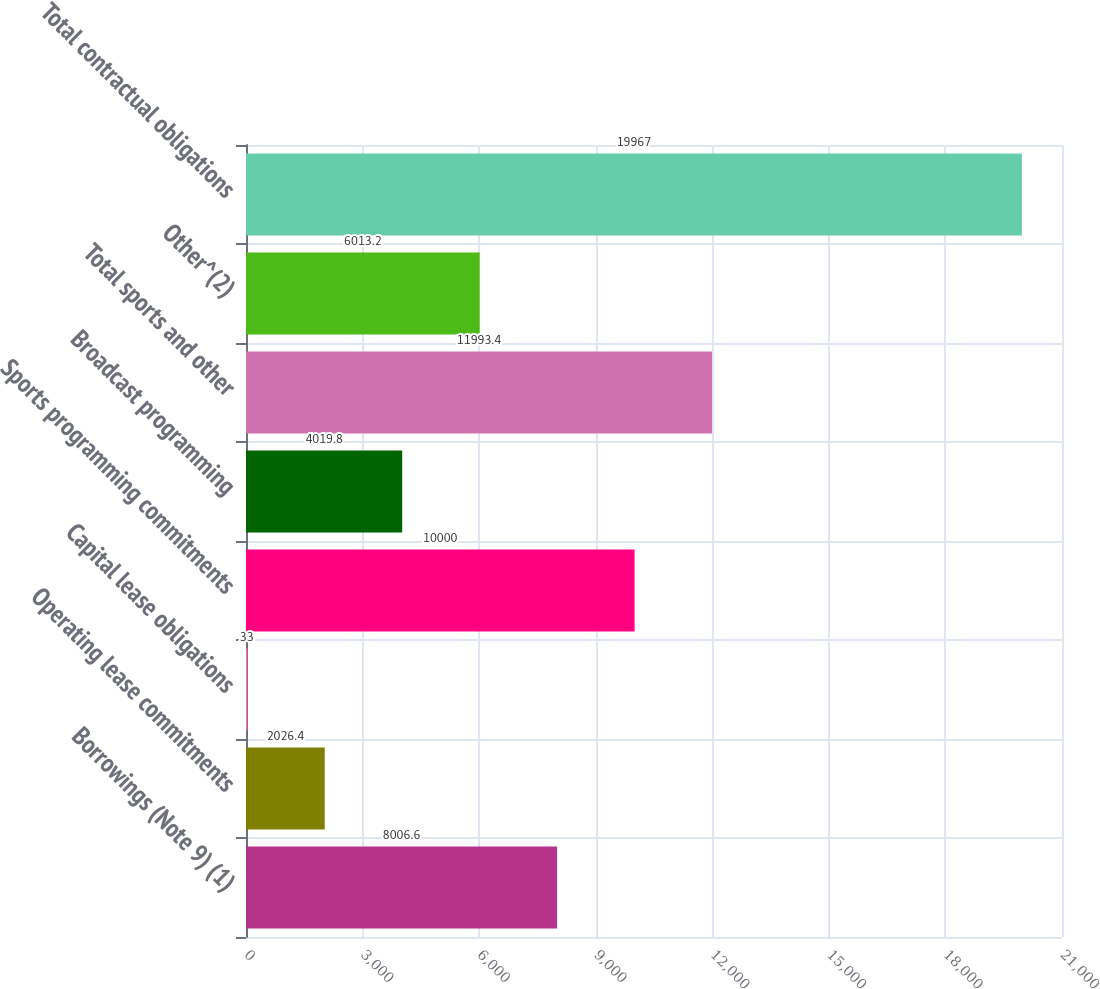Convert chart. <chart><loc_0><loc_0><loc_500><loc_500><bar_chart><fcel>Borrowings (Note 9) (1)<fcel>Operating lease commitments<fcel>Capital lease obligations<fcel>Sports programming commitments<fcel>Broadcast programming<fcel>Total sports and other<fcel>Other^(2)<fcel>Total contractual obligations<nl><fcel>8006.6<fcel>2026.4<fcel>33<fcel>10000<fcel>4019.8<fcel>11993.4<fcel>6013.2<fcel>19967<nl></chart> 